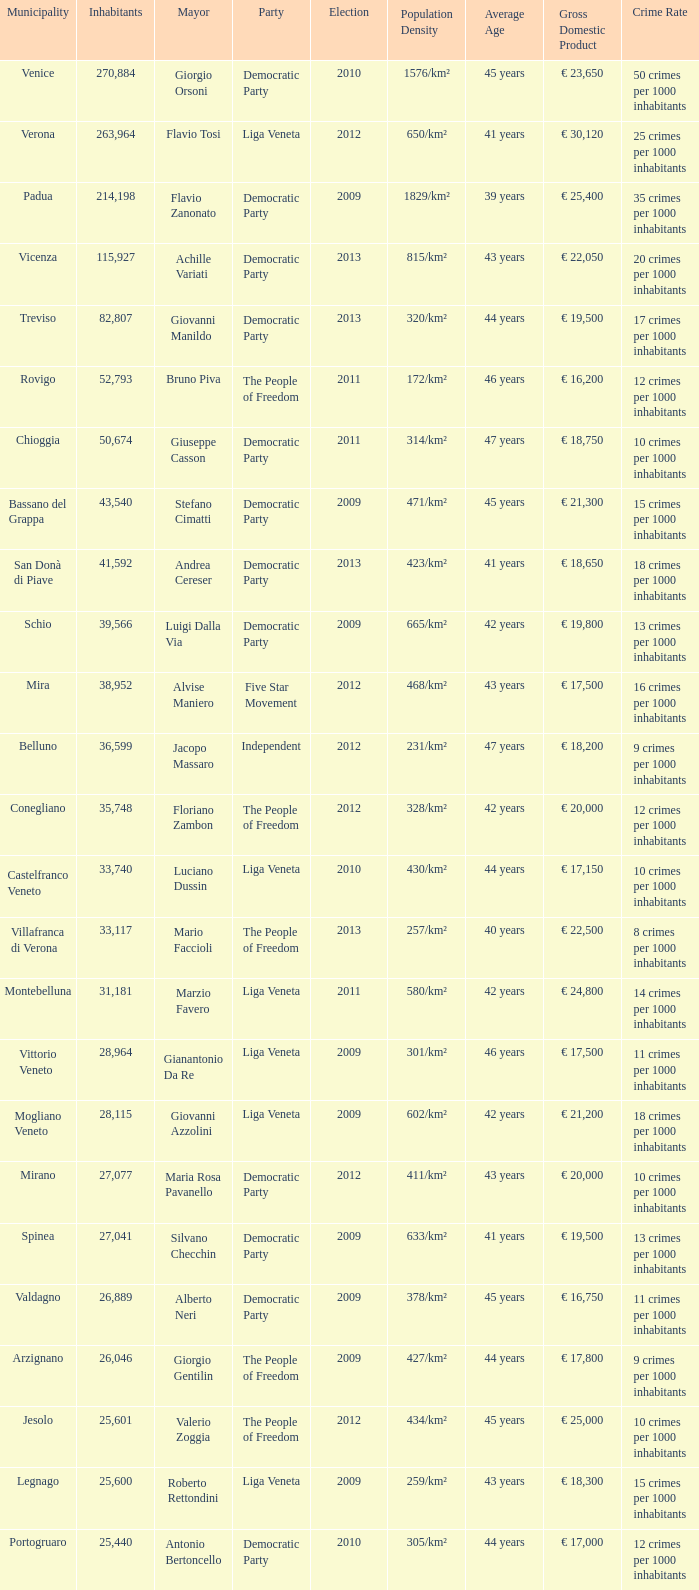How many elections had more than 36,599 inhabitants when Mayor was giovanni manildo? 1.0. 